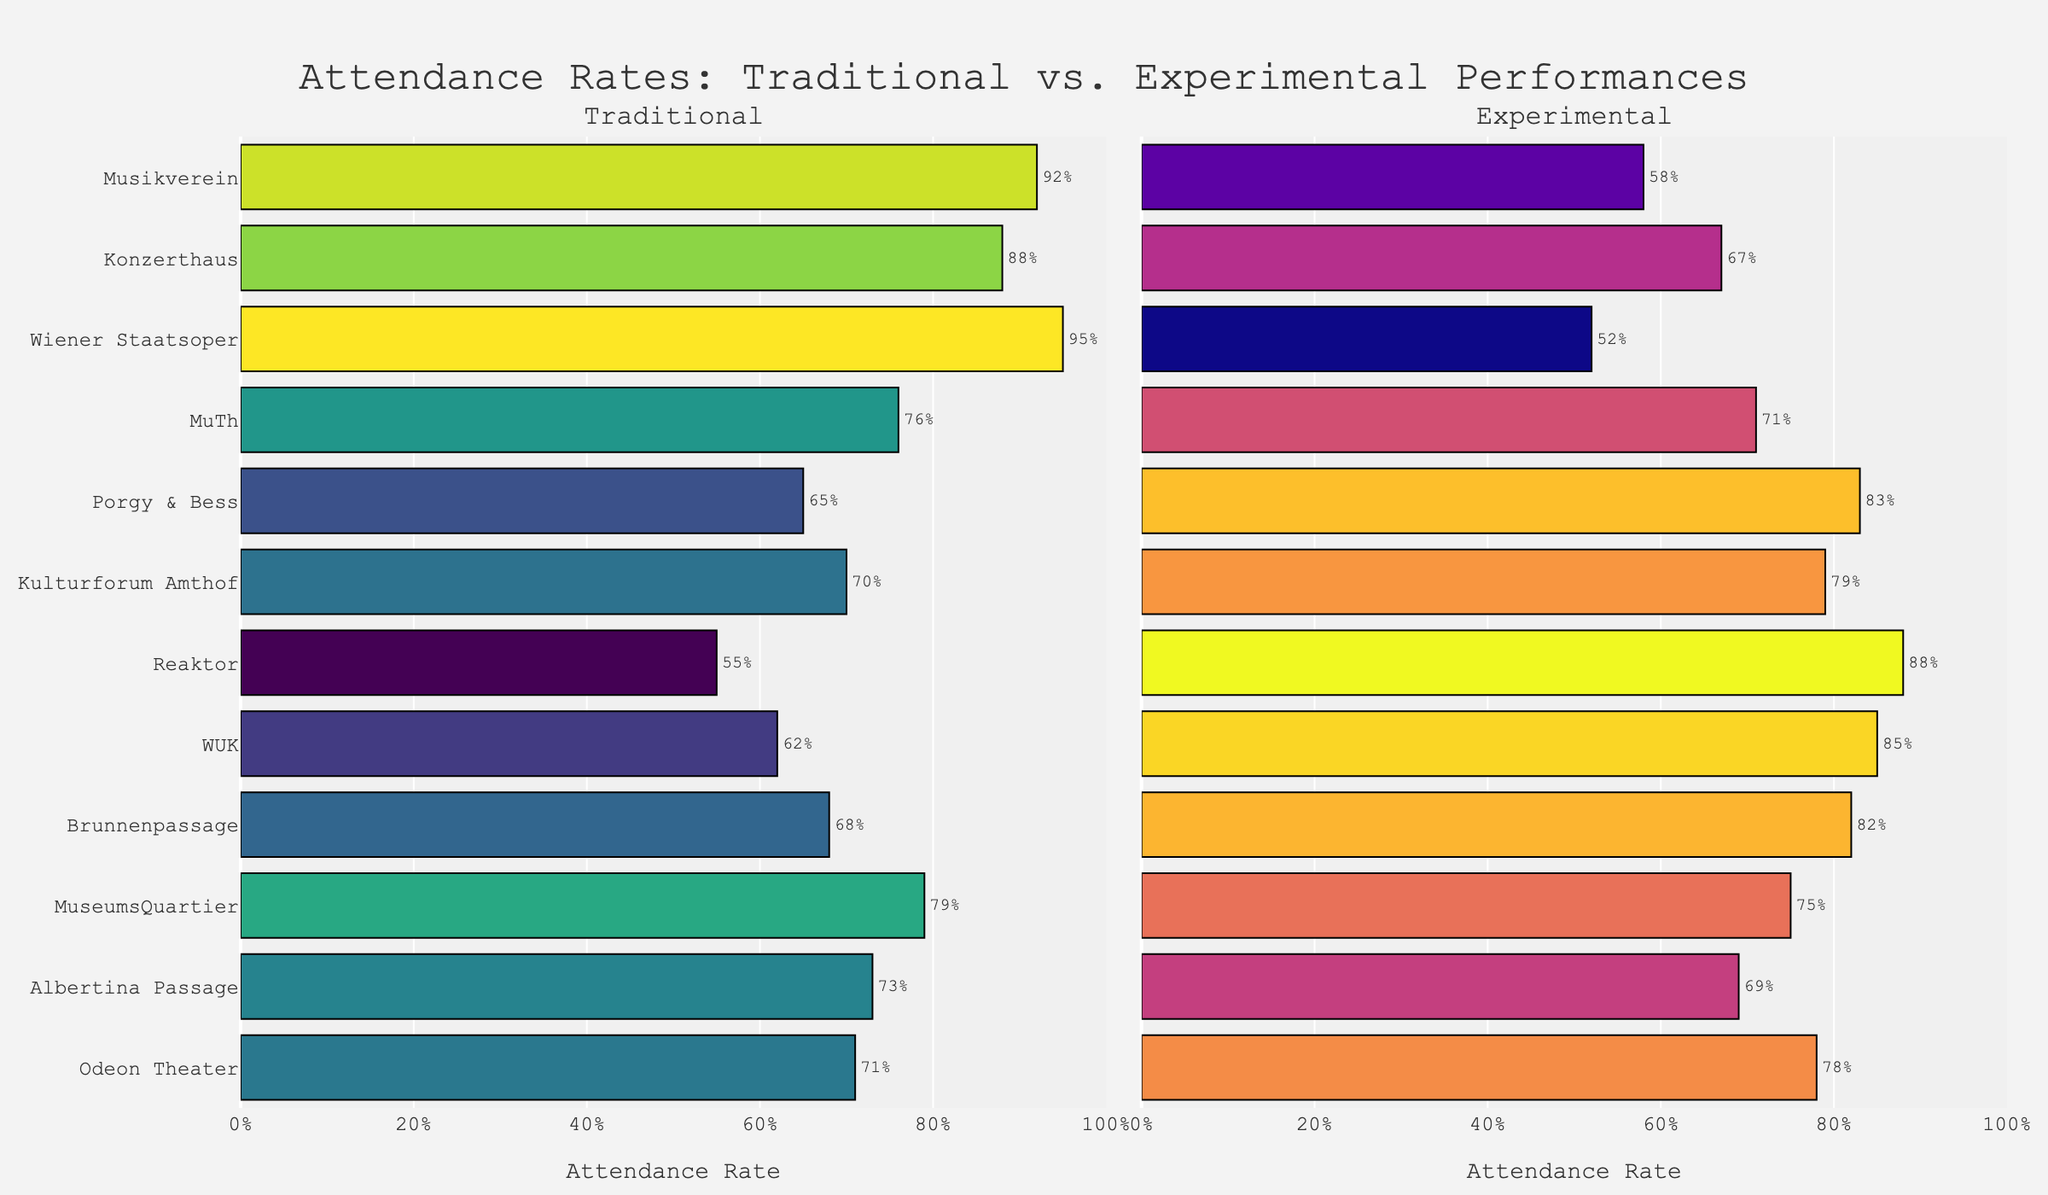Which concert hall has the highest attendance rate for traditional performances? The bar chart shows the attendance rates for each concert hall. The highest bar in the "Traditional" subplot belongs to Wiener Staatsoper with a value of 95%.
Answer: Wiener Staatsoper How does the attendance rate at experimental performances compare between Porgy & Bess and WUK? In the subplot for "Experimental" performances, the bar for Porgy & Bess shows 83% while WUK shows 85%.
Answer: WUK has a higher rate What is the average attendance rate for experimental performances across all concert halls? Sum the experimental performance attendance rates and divide by the number of concert halls: (58+67+52+71+83+79+88+85+82+75+69+78) / 12 = 71.17%.
Answer: 71.17% Which concert hall has a significantly higher attendance rate for experimental performances compared to traditional ones? In both subplots, compare the bars. Reaktor shows an experimental attendance of 88% and traditional attendance of 55%, which is a significant difference.
Answer: Reaktor What is the difference in attendance rates for traditional performances between Musikverein and Konzerthaus? The traditional attendance rates are 92% for Musikverein and 88% for Konzerthaus. The difference is 92% - 88% = 4%.
Answer: 4% Which concert hall has the most balanced attendance rates between traditional and experimental performances? Look for the smallest difference between the two attendance rates. MuTh has 76% for traditional and 71% for experimental, a difference of 5%.
Answer: MuTh How much higher is the attendance rate for traditional performances at Wiener Staatsoper compared to experimental performances? Wiener Staatsoper has a traditional attendance of 95% and experimental of 52%. The difference is 95% - 52% = 43%.
Answer: 43% Which concert hall has the lowest attendance rate for traditional performances? The lowest bar in the "Traditional" subplot is for Reaktor with a rate of 55%.
Answer: Reaktor 